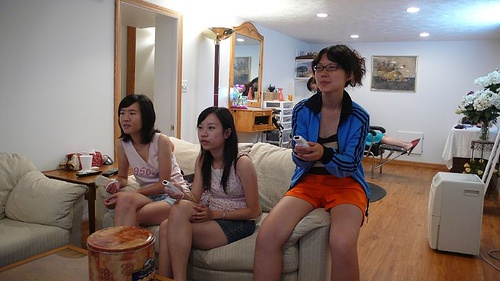Describe the objects in this image and their specific colors. I can see people in gray, maroon, black, brown, and navy tones, people in gray, black, brown, and maroon tones, couch in gray, black, and darkgray tones, couch in gray and black tones, and people in gray, brown, maroon, and black tones in this image. 